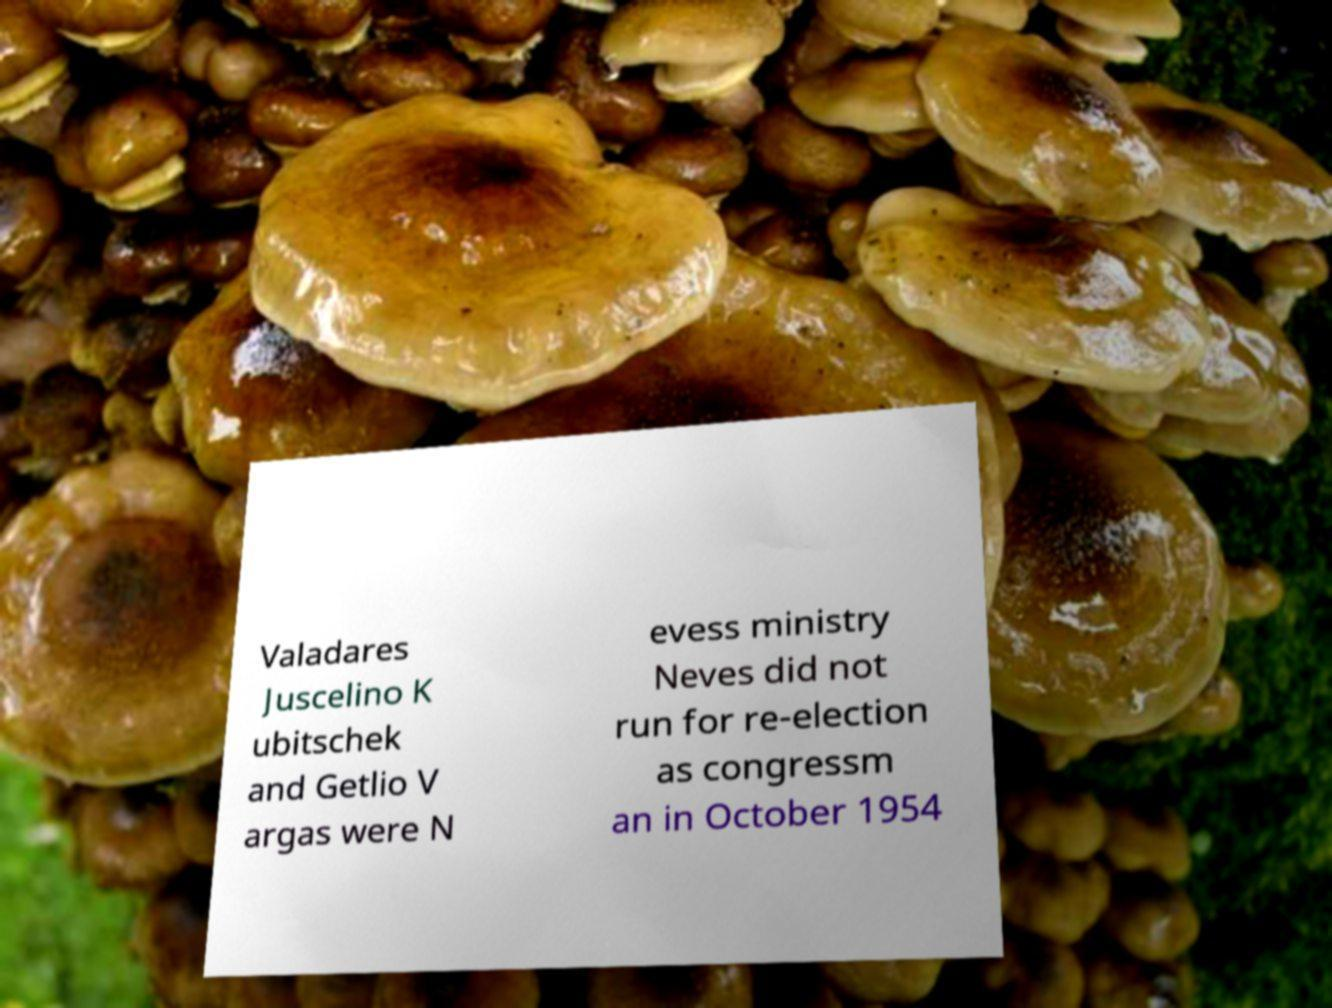For documentation purposes, I need the text within this image transcribed. Could you provide that? Valadares Juscelino K ubitschek and Getlio V argas were N evess ministry Neves did not run for re-election as congressm an in October 1954 